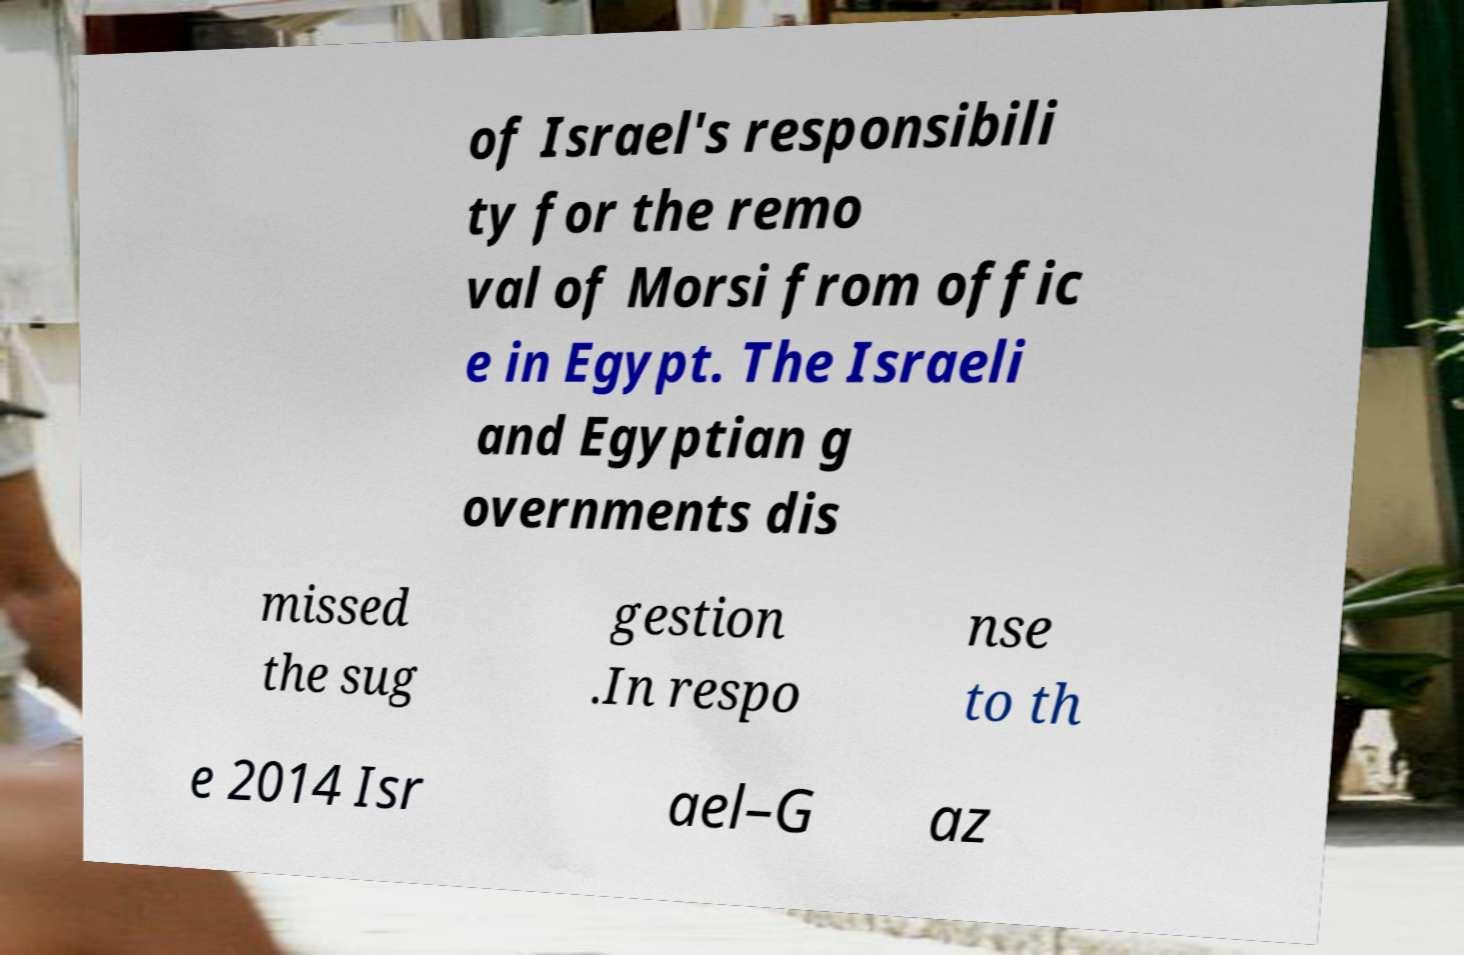Can you read and provide the text displayed in the image?This photo seems to have some interesting text. Can you extract and type it out for me? of Israel's responsibili ty for the remo val of Morsi from offic e in Egypt. The Israeli and Egyptian g overnments dis missed the sug gestion .In respo nse to th e 2014 Isr ael–G az 